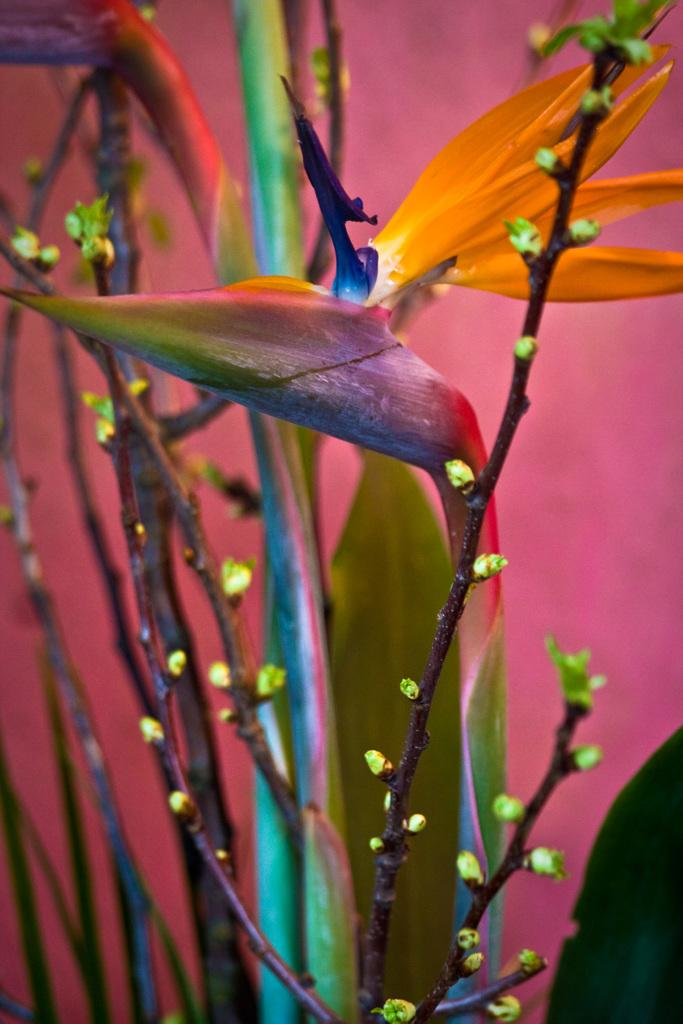What type of plant can be seen in the image? There is a colorful plant in the image. What color is the background of the image? The background of the image is pink. What type of magic is being performed on the plant in the image? There is no magic being performed on the plant in the image; it is a static image of a colorful plant. What kind of quartz can be seen in the image? There is no quartz present in the image; it features a colorful plant and a pink background. 